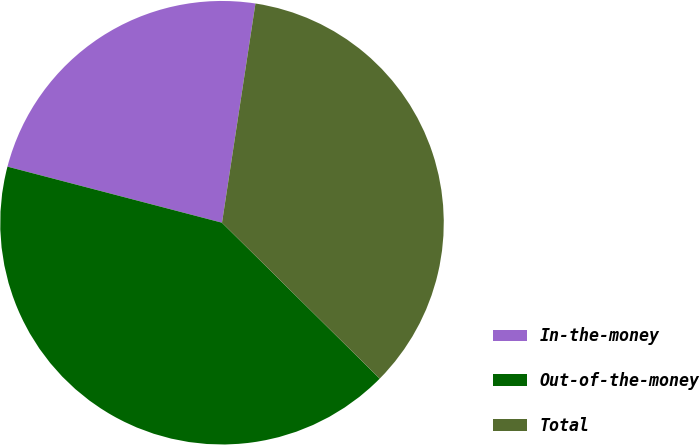Convert chart. <chart><loc_0><loc_0><loc_500><loc_500><pie_chart><fcel>In-the-money<fcel>Out-of-the-money<fcel>Total<nl><fcel>23.34%<fcel>41.66%<fcel>35.0%<nl></chart> 